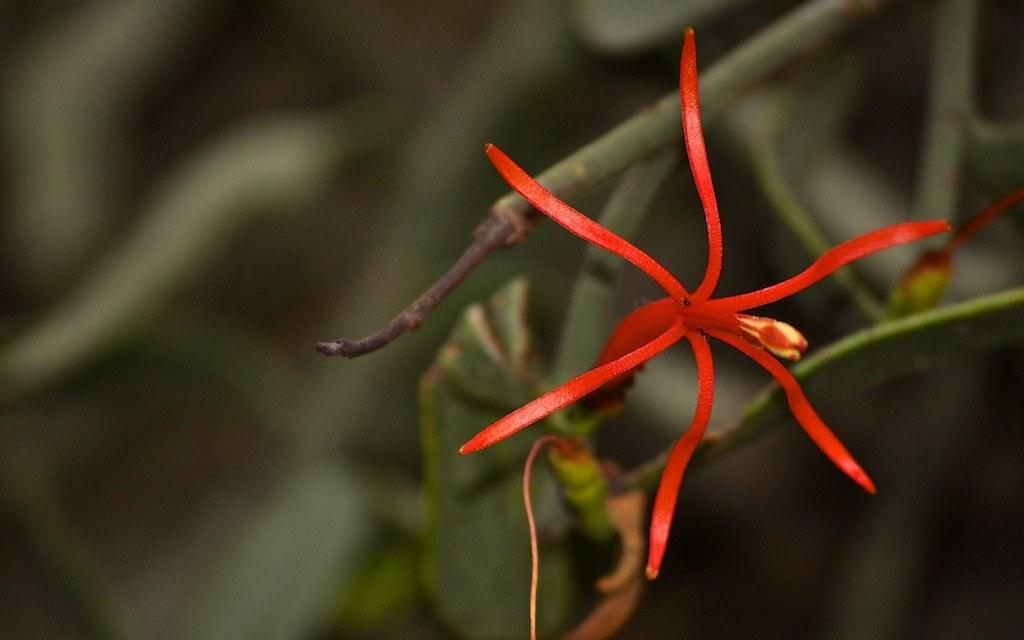What is the main subject of the image? There is a flower in the image. What type of wealth is being protested against in the image? There is no reference to wealth or protest in the image; it features a flower. 